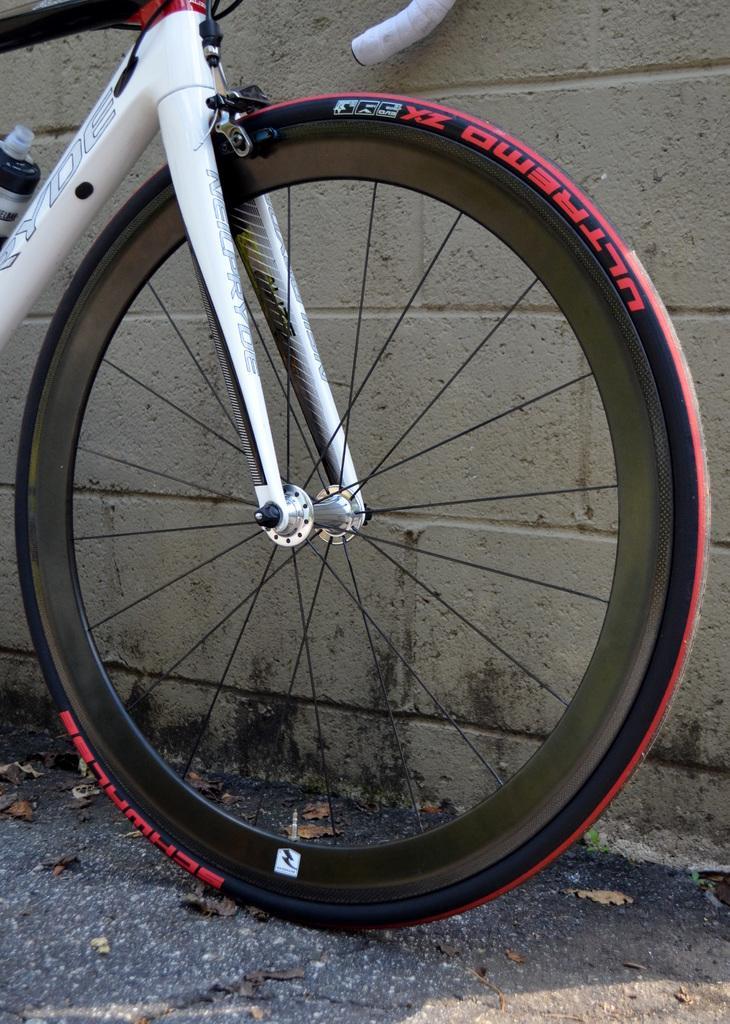Could you give a brief overview of what you see in this image? In this image there is a bicycle on a road, in the background there is a wall. 